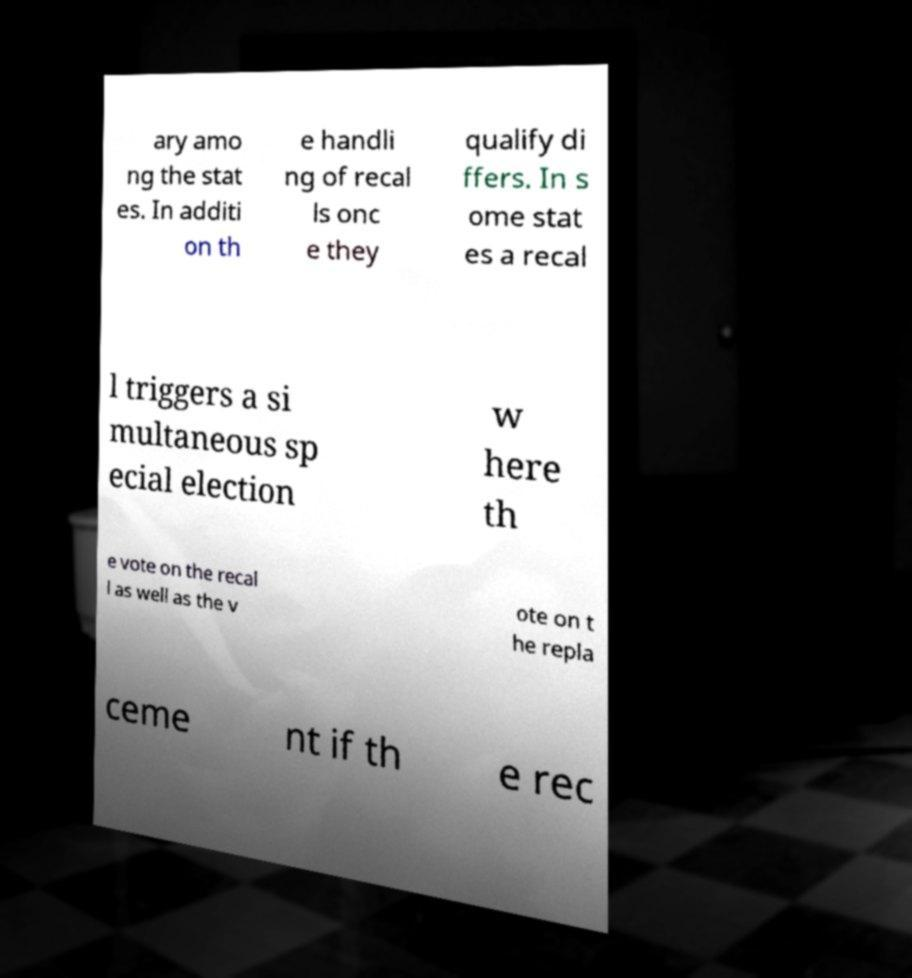Please identify and transcribe the text found in this image. ary amo ng the stat es. In additi on th e handli ng of recal ls onc e they qualify di ffers. In s ome stat es a recal l triggers a si multaneous sp ecial election w here th e vote on the recal l as well as the v ote on t he repla ceme nt if th e rec 